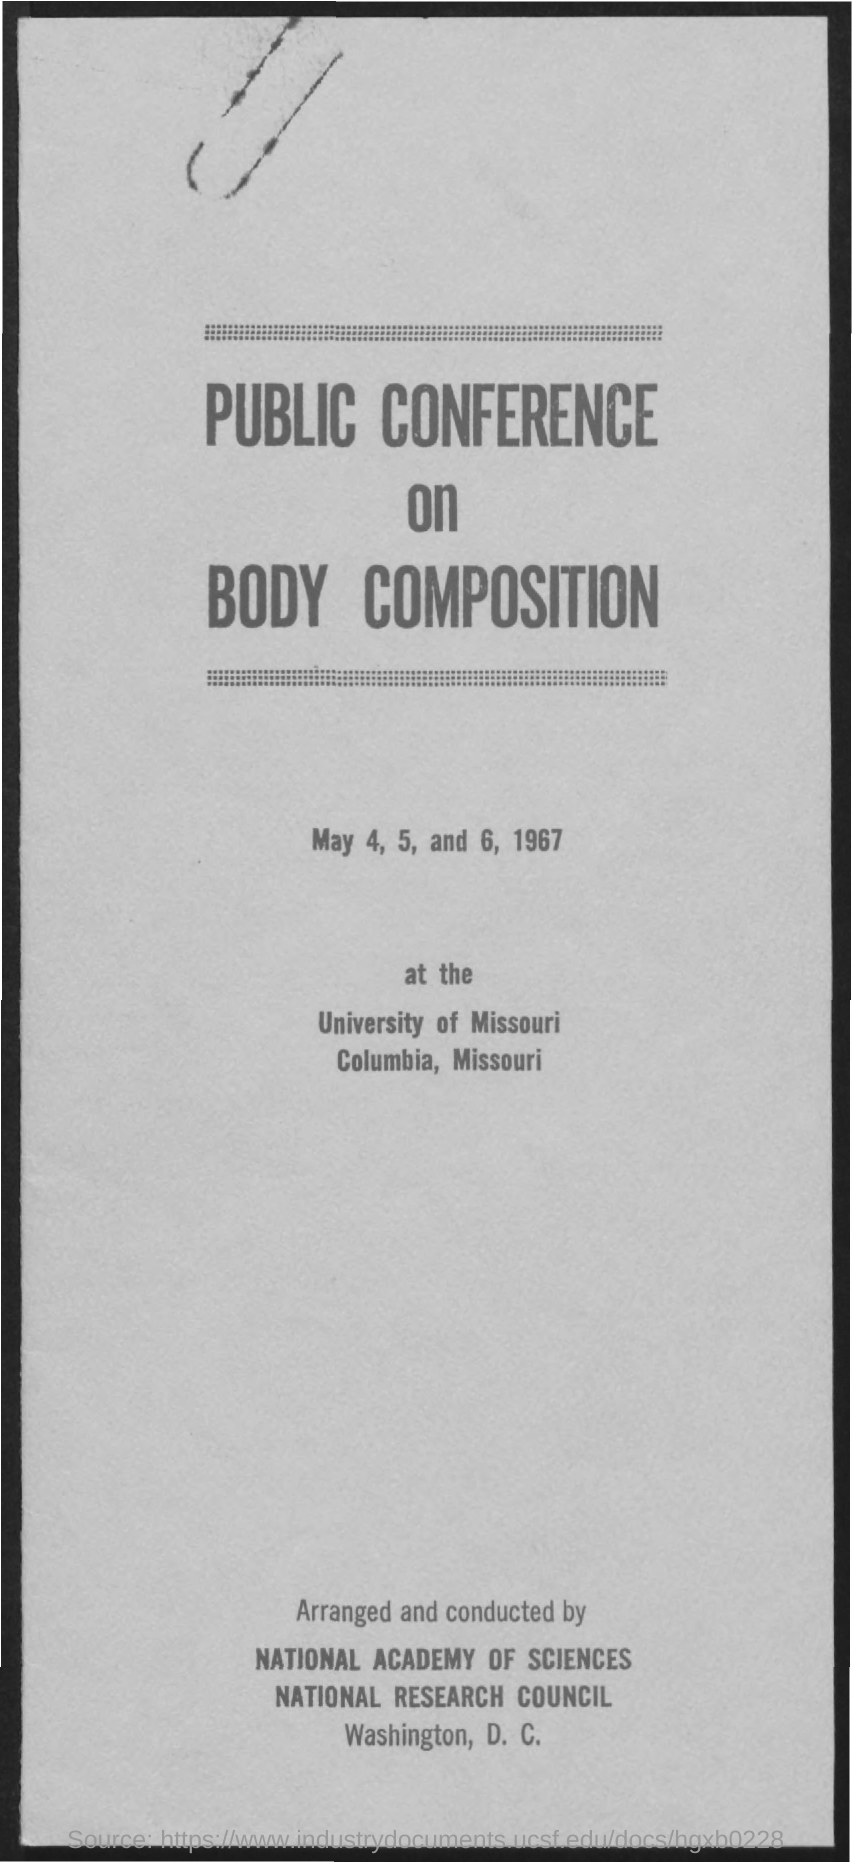What is the title of the document?
Your response must be concise. Public conference on body composition. When is the public conference dated for?
Keep it short and to the point. May 4, 5 and 6, 1967. Which is the venue of public conference on body composition?
Give a very brief answer. University of Missouri Columbia Missouri. 